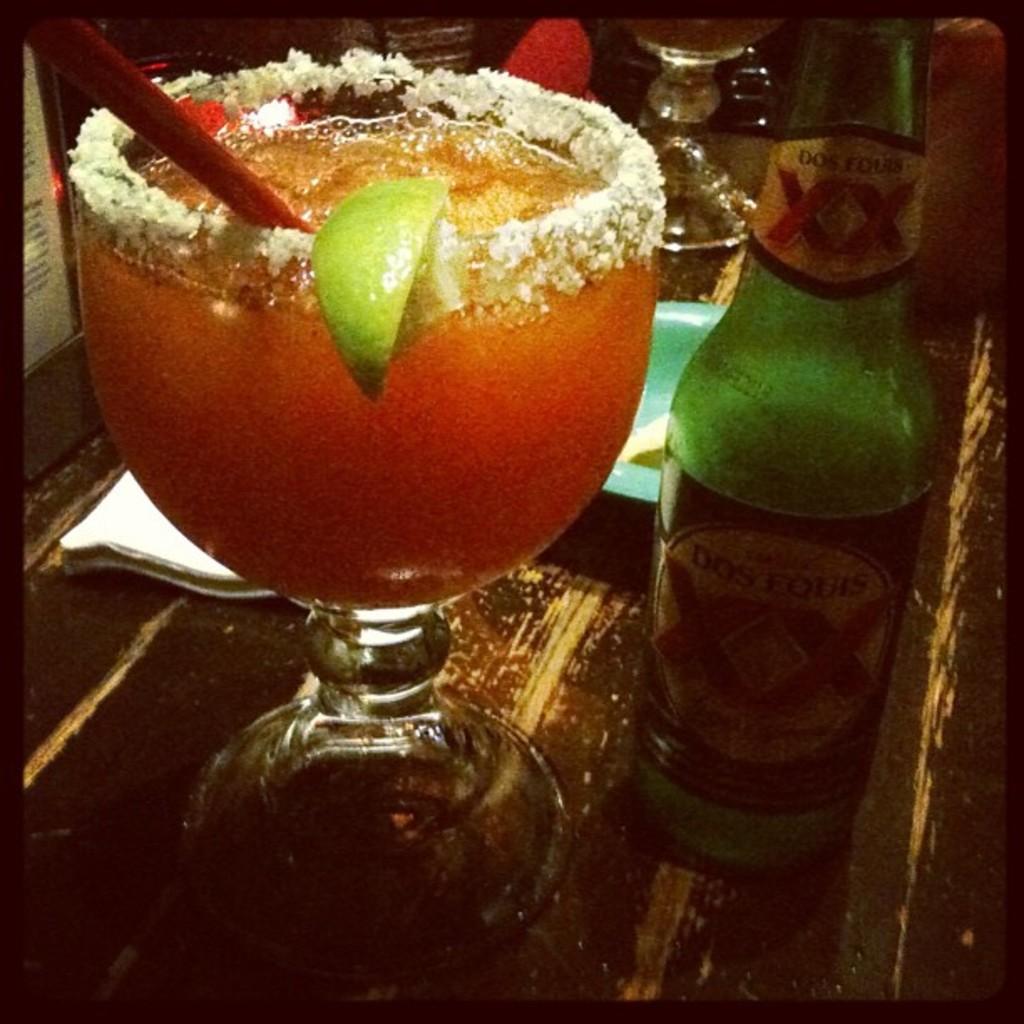What is the beer?
Give a very brief answer. Dos equis. What fruit is on this glass?
Keep it short and to the point. Answering does not require reading text in the image. 